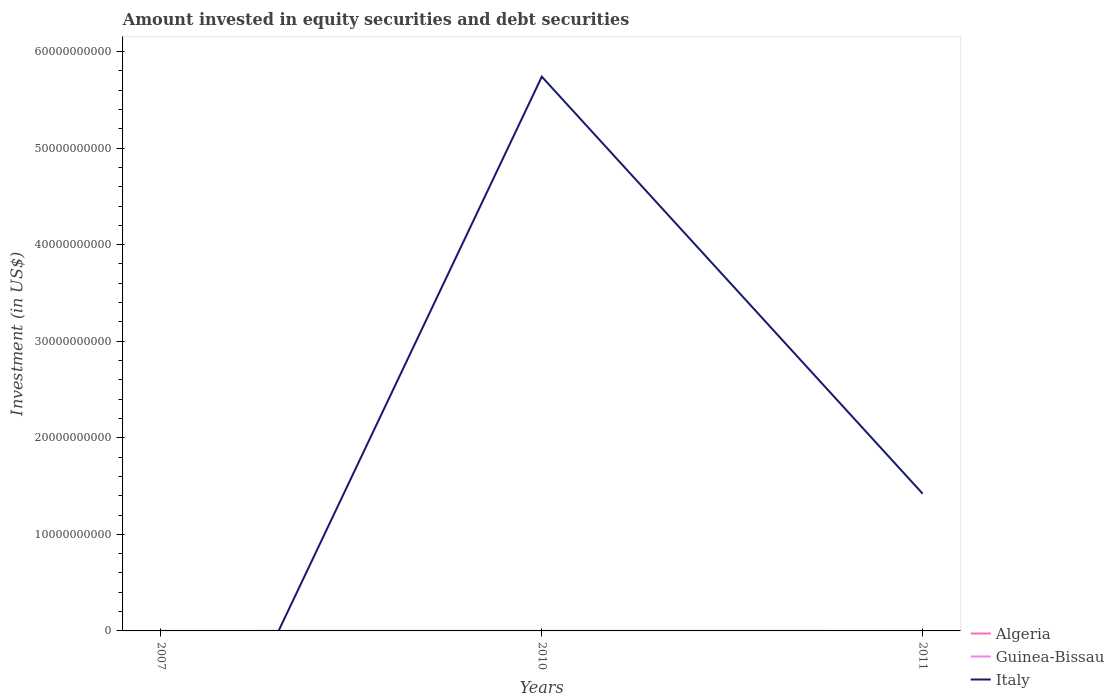Does the line corresponding to Guinea-Bissau intersect with the line corresponding to Italy?
Your answer should be compact. Yes. Is the number of lines equal to the number of legend labels?
Provide a succinct answer. No. What is the total amount invested in equity securities and debt securities in Guinea-Bissau in the graph?
Offer a very short reply. 1.16e+06. What is the difference between the highest and the second highest amount invested in equity securities and debt securities in Algeria?
Your response must be concise. 1.66e+05. How many lines are there?
Offer a terse response. 3. Are the values on the major ticks of Y-axis written in scientific E-notation?
Ensure brevity in your answer.  No. Where does the legend appear in the graph?
Offer a terse response. Bottom right. How many legend labels are there?
Your answer should be compact. 3. How are the legend labels stacked?
Make the answer very short. Vertical. What is the title of the graph?
Keep it short and to the point. Amount invested in equity securities and debt securities. What is the label or title of the X-axis?
Provide a short and direct response. Years. What is the label or title of the Y-axis?
Your response must be concise. Investment (in US$). What is the Investment (in US$) of Algeria in 2007?
Offer a very short reply. 1.66e+05. What is the Investment (in US$) in Guinea-Bissau in 2007?
Offer a terse response. 5.01e+06. What is the Investment (in US$) of Guinea-Bissau in 2010?
Your answer should be compact. 5.61e+06. What is the Investment (in US$) of Italy in 2010?
Provide a succinct answer. 5.74e+1. What is the Investment (in US$) in Guinea-Bissau in 2011?
Offer a very short reply. 4.45e+06. What is the Investment (in US$) of Italy in 2011?
Offer a terse response. 1.42e+1. Across all years, what is the maximum Investment (in US$) in Algeria?
Ensure brevity in your answer.  1.66e+05. Across all years, what is the maximum Investment (in US$) of Guinea-Bissau?
Your answer should be very brief. 5.61e+06. Across all years, what is the maximum Investment (in US$) in Italy?
Offer a very short reply. 5.74e+1. Across all years, what is the minimum Investment (in US$) in Algeria?
Keep it short and to the point. 0. Across all years, what is the minimum Investment (in US$) of Guinea-Bissau?
Offer a terse response. 4.45e+06. What is the total Investment (in US$) of Algeria in the graph?
Provide a short and direct response. 1.66e+05. What is the total Investment (in US$) in Guinea-Bissau in the graph?
Offer a very short reply. 1.51e+07. What is the total Investment (in US$) of Italy in the graph?
Your answer should be compact. 7.16e+1. What is the difference between the Investment (in US$) of Guinea-Bissau in 2007 and that in 2010?
Ensure brevity in your answer.  -6.00e+05. What is the difference between the Investment (in US$) of Guinea-Bissau in 2007 and that in 2011?
Keep it short and to the point. 5.64e+05. What is the difference between the Investment (in US$) in Guinea-Bissau in 2010 and that in 2011?
Offer a very short reply. 1.16e+06. What is the difference between the Investment (in US$) of Italy in 2010 and that in 2011?
Offer a very short reply. 4.32e+1. What is the difference between the Investment (in US$) of Algeria in 2007 and the Investment (in US$) of Guinea-Bissau in 2010?
Keep it short and to the point. -5.44e+06. What is the difference between the Investment (in US$) of Algeria in 2007 and the Investment (in US$) of Italy in 2010?
Make the answer very short. -5.74e+1. What is the difference between the Investment (in US$) in Guinea-Bissau in 2007 and the Investment (in US$) in Italy in 2010?
Your answer should be very brief. -5.74e+1. What is the difference between the Investment (in US$) of Algeria in 2007 and the Investment (in US$) of Guinea-Bissau in 2011?
Offer a very short reply. -4.28e+06. What is the difference between the Investment (in US$) of Algeria in 2007 and the Investment (in US$) of Italy in 2011?
Make the answer very short. -1.42e+1. What is the difference between the Investment (in US$) of Guinea-Bissau in 2007 and the Investment (in US$) of Italy in 2011?
Provide a succinct answer. -1.42e+1. What is the difference between the Investment (in US$) of Guinea-Bissau in 2010 and the Investment (in US$) of Italy in 2011?
Keep it short and to the point. -1.42e+1. What is the average Investment (in US$) of Algeria per year?
Your response must be concise. 5.54e+04. What is the average Investment (in US$) of Guinea-Bissau per year?
Offer a very short reply. 5.02e+06. What is the average Investment (in US$) of Italy per year?
Make the answer very short. 2.39e+1. In the year 2007, what is the difference between the Investment (in US$) of Algeria and Investment (in US$) of Guinea-Bissau?
Ensure brevity in your answer.  -4.84e+06. In the year 2010, what is the difference between the Investment (in US$) in Guinea-Bissau and Investment (in US$) in Italy?
Make the answer very short. -5.74e+1. In the year 2011, what is the difference between the Investment (in US$) of Guinea-Bissau and Investment (in US$) of Italy?
Your answer should be compact. -1.42e+1. What is the ratio of the Investment (in US$) of Guinea-Bissau in 2007 to that in 2010?
Your response must be concise. 0.89. What is the ratio of the Investment (in US$) of Guinea-Bissau in 2007 to that in 2011?
Provide a short and direct response. 1.13. What is the ratio of the Investment (in US$) in Guinea-Bissau in 2010 to that in 2011?
Offer a terse response. 1.26. What is the ratio of the Investment (in US$) in Italy in 2010 to that in 2011?
Your response must be concise. 4.04. What is the difference between the highest and the second highest Investment (in US$) of Guinea-Bissau?
Ensure brevity in your answer.  6.00e+05. What is the difference between the highest and the lowest Investment (in US$) of Algeria?
Keep it short and to the point. 1.66e+05. What is the difference between the highest and the lowest Investment (in US$) of Guinea-Bissau?
Provide a succinct answer. 1.16e+06. What is the difference between the highest and the lowest Investment (in US$) of Italy?
Give a very brief answer. 5.74e+1. 